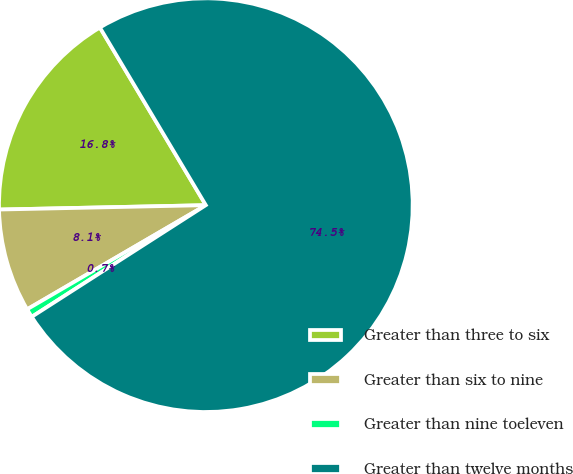Convert chart. <chart><loc_0><loc_0><loc_500><loc_500><pie_chart><fcel>Greater than three to six<fcel>Greater than six to nine<fcel>Greater than nine toeleven<fcel>Greater than twelve months<nl><fcel>16.78%<fcel>8.06%<fcel>0.68%<fcel>74.48%<nl></chart> 